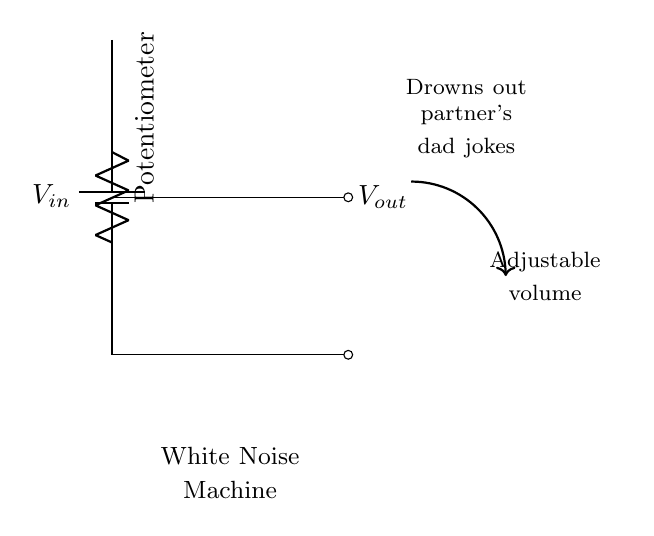What type of component is the potentiometer? The diagram shows a potentiometer used in the circuit, which is a type of variable resistor that can adjust the resistance value and thereby control the output voltage.
Answer: Potentiometer What is the purpose of the white noise machine? The diagram indicates that the white noise machine is intended to drown out undesirable sounds, specifically partner's dad jokes, providing a comedic context highlighting the application of the circuit.
Answer: Drown out dad jokes What is the output voltage connected to? The output voltage is connected to a node labeled with the term "Adjustable volume," indicating that the output can be varied based on the settings of the potentiometer to control the volume of the noise produced.
Answer: Adjustable volume How many resistances are in series in this circuit? In the voltage divider configuration depicted, there's only one effective resistance here, which comes from the potentiometer acting as the variable resistance rather than having multiple resistors in series.
Answer: One What happens if the potentiometer is turned fully to one side? When the potentiometer is turned fully to one side, it either allows maximum input voltage to appear at the output or can effectively short the circuit if configured to do so, resulting in maximum noise output.
Answer: Maximum output What effect does decreasing the resistance of the potentiometer have on the output voltage? Reducing the resistance of the potentiometer decreases the total resistance in the divider, hence increasing the output voltage available for the white noise generation, making it louder.
Answer: Increases output voltage 